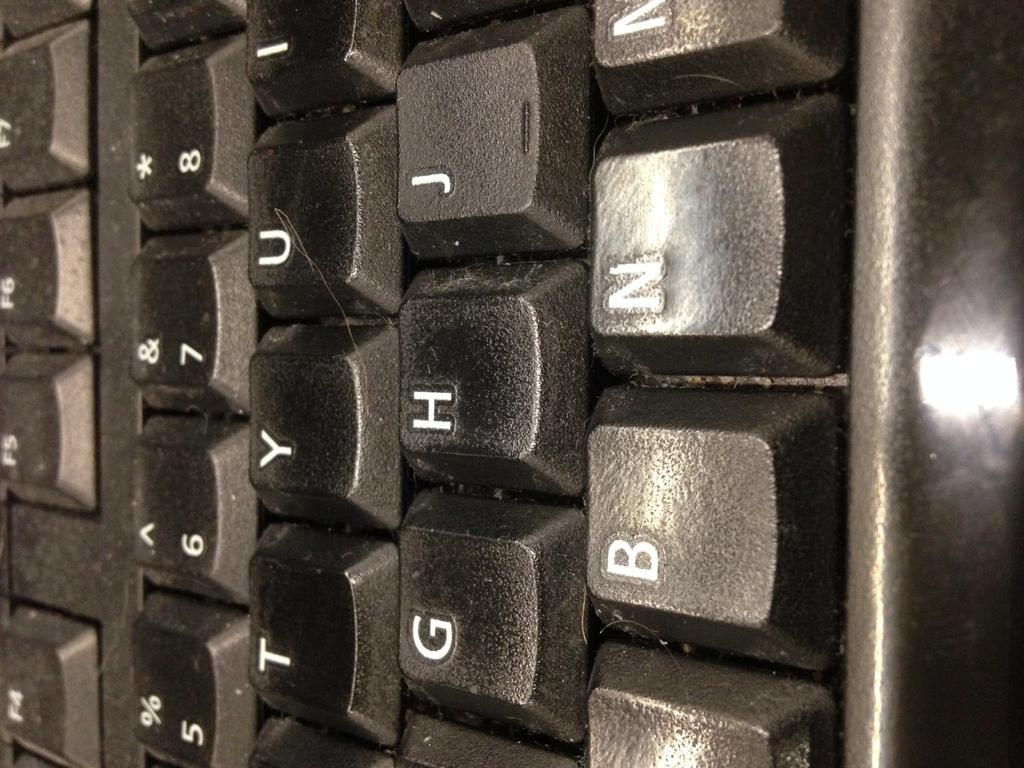<image>
Relay a brief, clear account of the picture shown. a very close closeup of a black keyboard with keys for G and H 